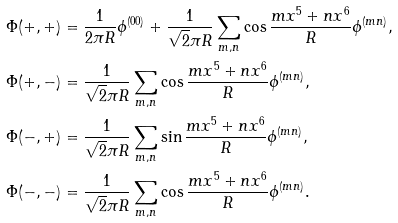<formula> <loc_0><loc_0><loc_500><loc_500>\Phi ( + , + ) & = \frac { 1 } { 2 \pi R } \phi ^ { ( 0 0 ) } + \frac { 1 } { \sqrt { 2 } \pi R } \sum _ { m , n } \cos \frac { m x ^ { 5 } + n x ^ { 6 } } { R } \phi ^ { ( m n ) } , \\ \Phi ( + , - ) & = \frac { 1 } { \sqrt { 2 } \pi R } \sum _ { m , n } \cos \frac { m x ^ { 5 } + n x ^ { 6 } } { R } \phi ^ { ( m n ) } , \\ \Phi ( - , + ) & = \frac { 1 } { \sqrt { 2 } \pi R } \sum _ { m , n } \sin \frac { m x ^ { 5 } + n x ^ { 6 } } { R } \phi ^ { ( m n ) } , \\ \Phi ( - , - ) & = \frac { 1 } { \sqrt { 2 } \pi R } \sum _ { m , n } \cos \frac { m x ^ { 5 } + n x ^ { 6 } } { R } \phi ^ { ( m n ) } .</formula> 